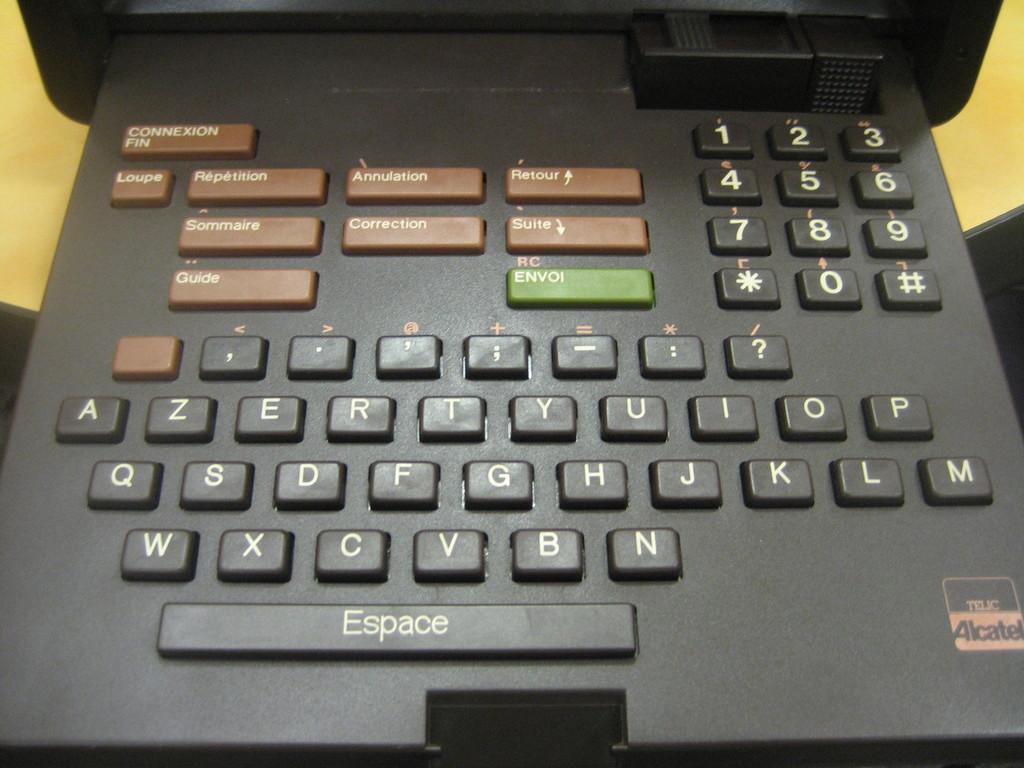What is printed on the spacebar?
Your response must be concise. Espace. What is on the upper left brown key?
Your response must be concise. Connexion fin. 